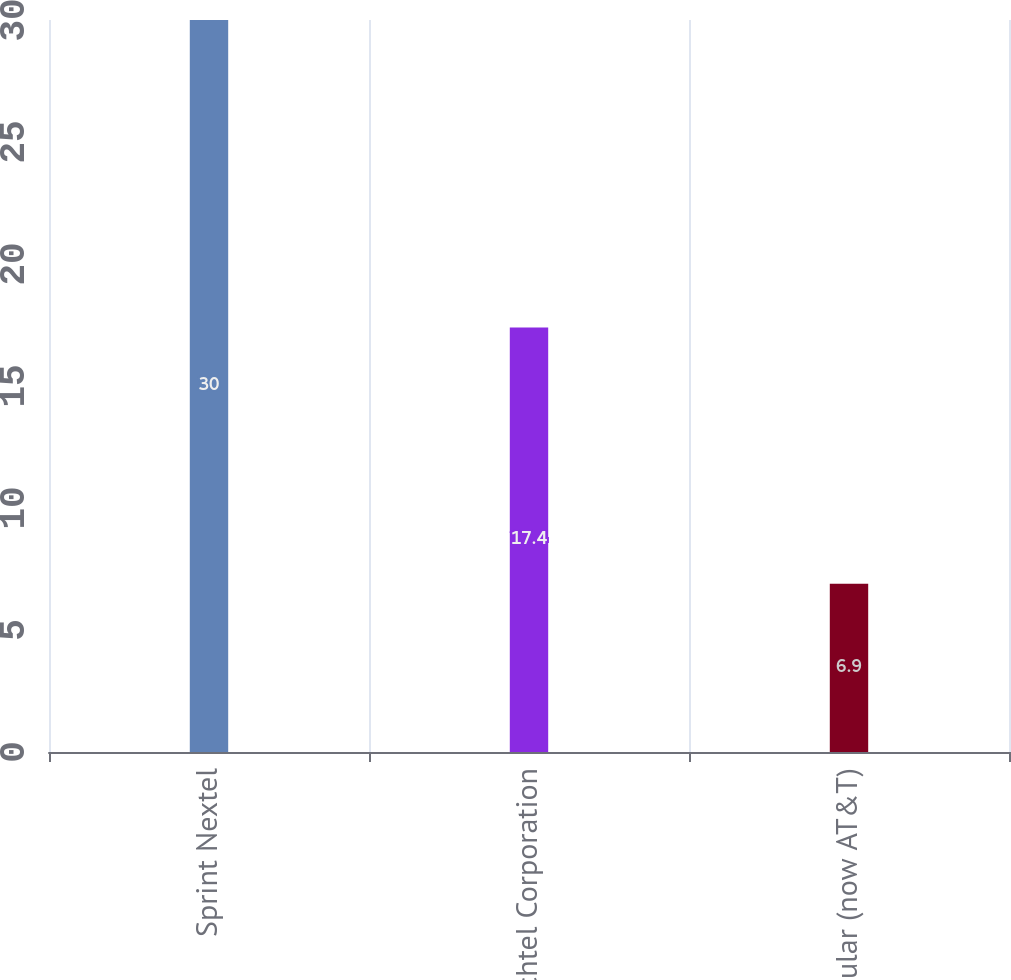Convert chart. <chart><loc_0><loc_0><loc_500><loc_500><bar_chart><fcel>Sprint Nextel<fcel>Bechtel Corporation<fcel>Cingular (now AT&T)<nl><fcel>30<fcel>17.4<fcel>6.9<nl></chart> 